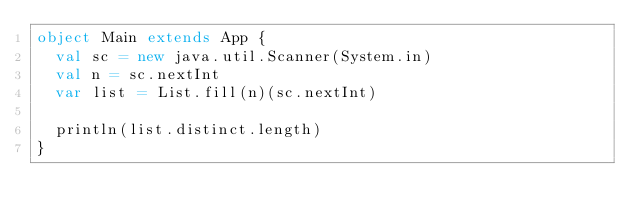<code> <loc_0><loc_0><loc_500><loc_500><_Scala_>object Main extends App {
  val sc = new java.util.Scanner(System.in)
  val n = sc.nextInt
  var list = List.fill(n)(sc.nextInt)

  println(list.distinct.length)
}</code> 